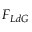<formula> <loc_0><loc_0><loc_500><loc_500>F _ { L d G }</formula> 